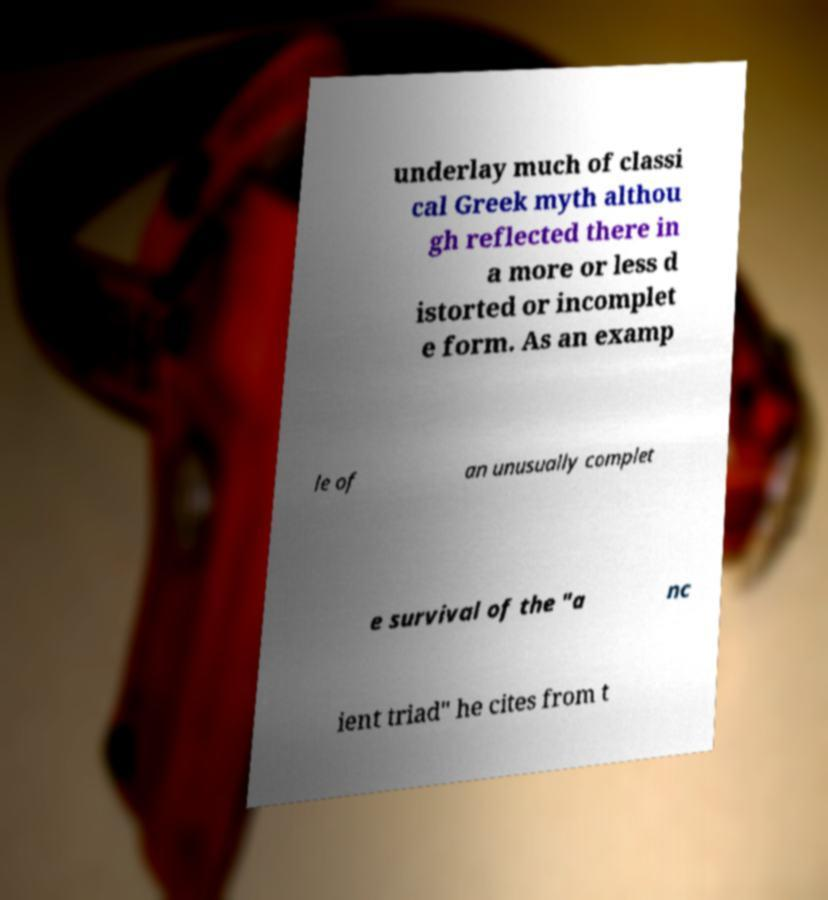For documentation purposes, I need the text within this image transcribed. Could you provide that? underlay much of classi cal Greek myth althou gh reflected there in a more or less d istorted or incomplet e form. As an examp le of an unusually complet e survival of the "a nc ient triad" he cites from t 